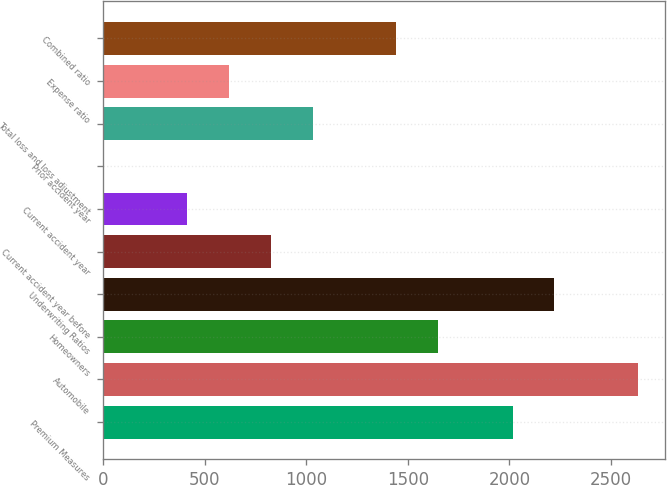Convert chart to OTSL. <chart><loc_0><loc_0><loc_500><loc_500><bar_chart><fcel>Premium Measures<fcel>Automobile<fcel>Homeowners<fcel>Underwriting Ratios<fcel>Current accident year before<fcel>Current accident year<fcel>Prior accident year<fcel>Total loss and loss adjustment<fcel>Expense ratio<fcel>Combined ratio<nl><fcel>2015<fcel>2633.45<fcel>1649.7<fcel>2221.15<fcel>825.1<fcel>412.8<fcel>0.5<fcel>1031.25<fcel>618.95<fcel>1443.55<nl></chart> 